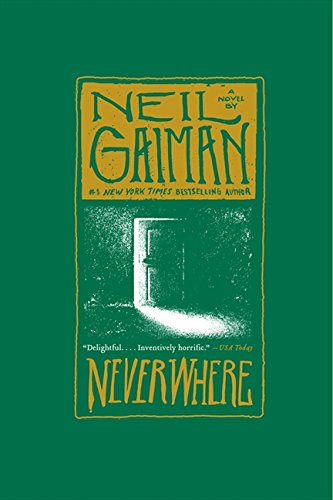Is this book related to Science Fiction & Fantasy? Yes, 'Neverwhere: A Novel' is indeed related to Science Fiction & Fantasy, exploring themes of urban fantasy and alternate realities. 